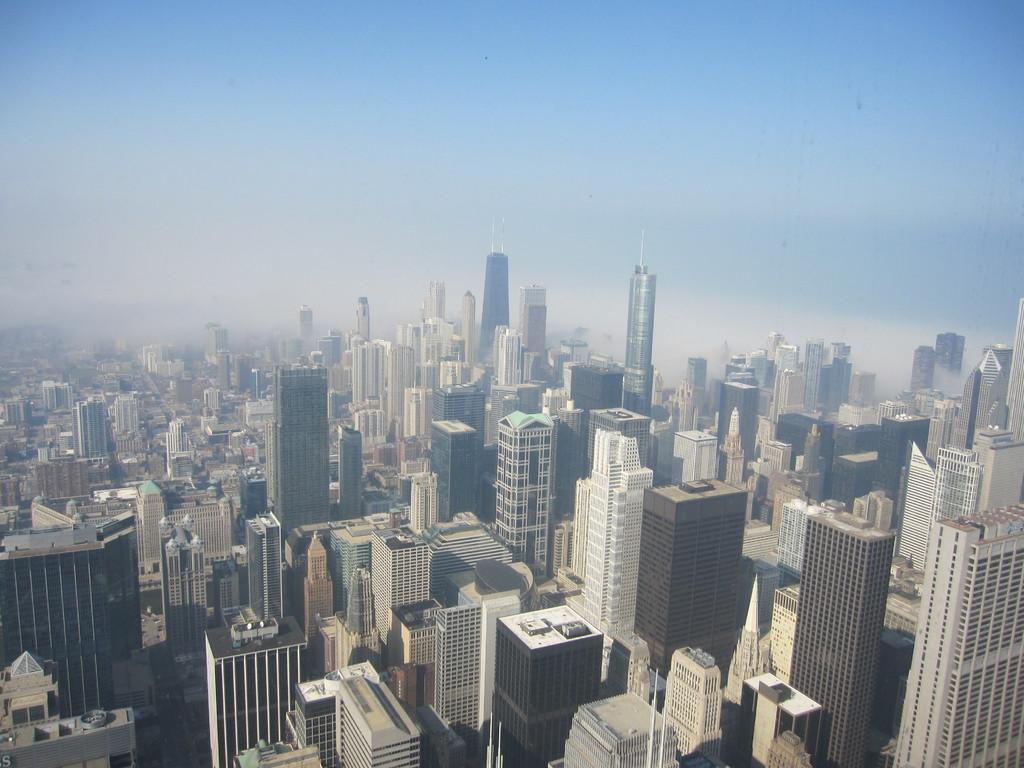What type of structures are present in the image? There are big buildings in the image. What can be seen at the top of the image? The sky is visible at the top of the image. What type of rice is being crushed in a bottle in the image? There is no rice, crushing, or bottle present in the image. 